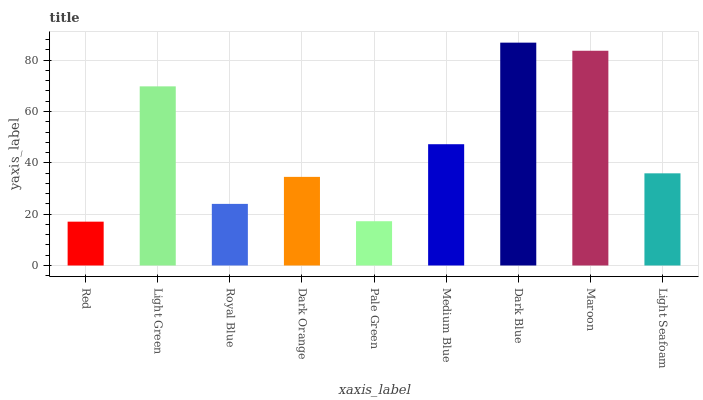Is Red the minimum?
Answer yes or no. Yes. Is Dark Blue the maximum?
Answer yes or no. Yes. Is Light Green the minimum?
Answer yes or no. No. Is Light Green the maximum?
Answer yes or no. No. Is Light Green greater than Red?
Answer yes or no. Yes. Is Red less than Light Green?
Answer yes or no. Yes. Is Red greater than Light Green?
Answer yes or no. No. Is Light Green less than Red?
Answer yes or no. No. Is Light Seafoam the high median?
Answer yes or no. Yes. Is Light Seafoam the low median?
Answer yes or no. Yes. Is Medium Blue the high median?
Answer yes or no. No. Is Royal Blue the low median?
Answer yes or no. No. 